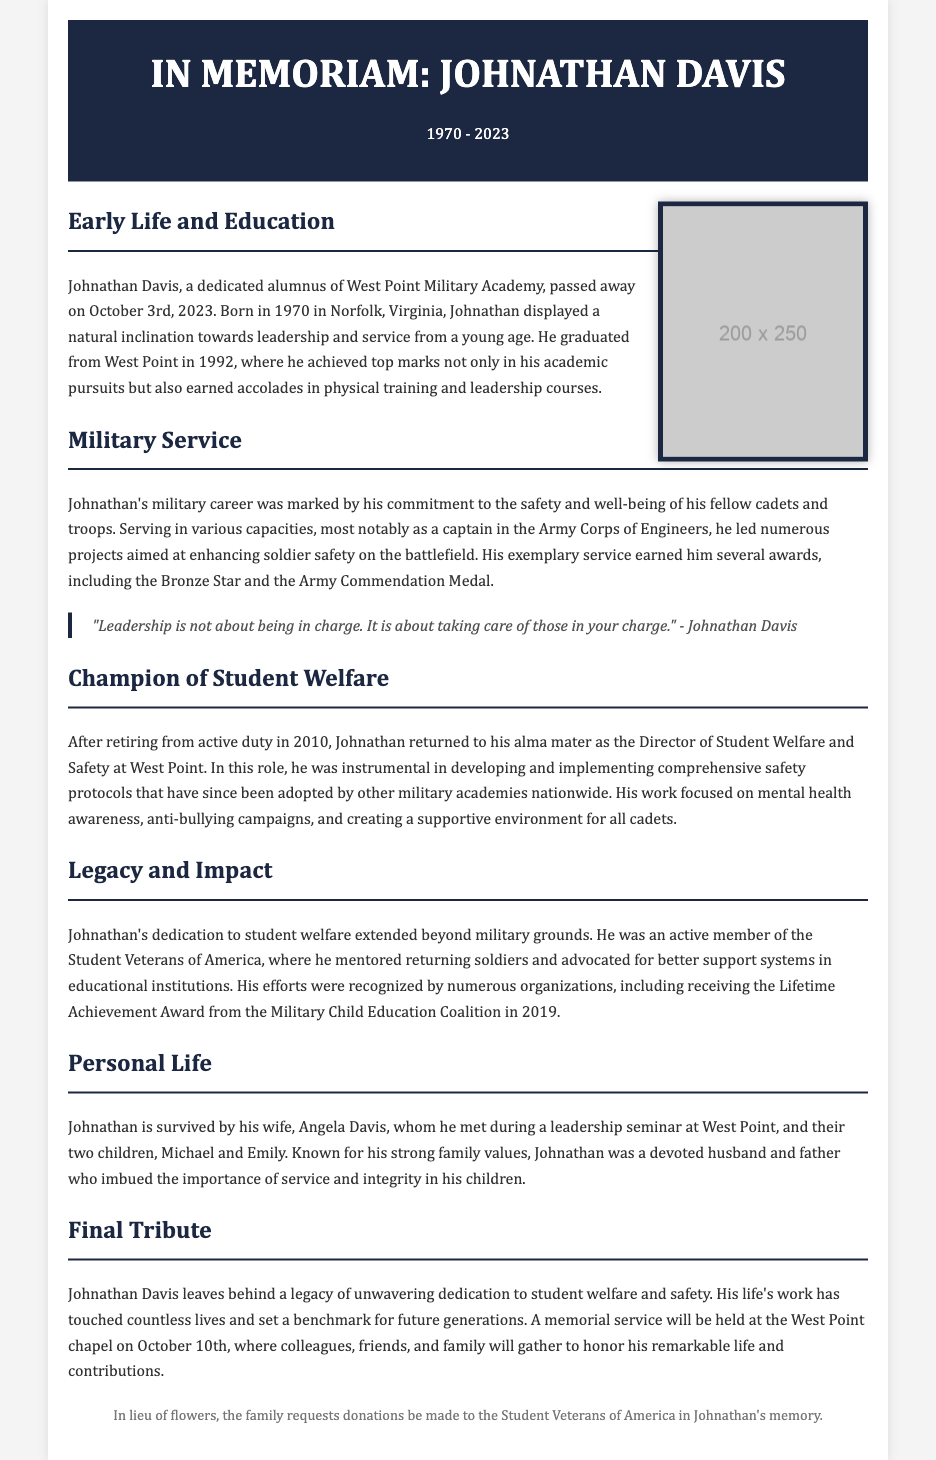what is the name of the deceased? The name of the deceased, as mentioned in the obituary, is Johnathan Davis.
Answer: Johnathan Davis what year did Johnathan graduate from West Point? The document states that Johnathan graduated from West Point in 1992.
Answer: 1992 what military rank did Johnathan achieve? According to the obituary, Johnathan served most notably as a captain in the Army Corps of Engineers.
Answer: captain when did Johnathan pass away? The obituary notes that Johnathan passed away on October 3rd, 2023.
Answer: October 3rd, 2023 what award did Johnathan receive for his military service? Johnathan earned several awards for his service, including the Bronze Star.
Answer: Bronze Star how many children did Johnathan have? The document mentions that Johnathan is survived by two children, Michael and Emily.
Answer: two what position did Johnathan hold at West Point after retiring? After retiring, Johnathan served as the Director of Student Welfare and Safety at West Point.
Answer: Director of Student Welfare and Safety what was one of Johnathan's contributions to student welfare? Johnathan was instrumental in developing comprehensive safety protocols for cadets.
Answer: safety protocols where will the memorial service for Johnathan be held? The memorial service is scheduled to be held at the West Point chapel.
Answer: West Point chapel 